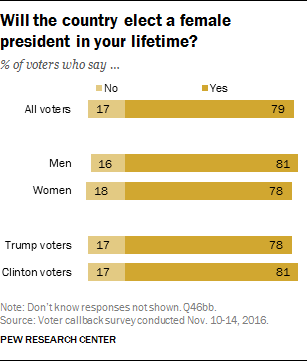Identify some key points in this picture. What is the highest value in the data type 'yes'? 81. It is not the case that there is a greater number of men without value than women. 